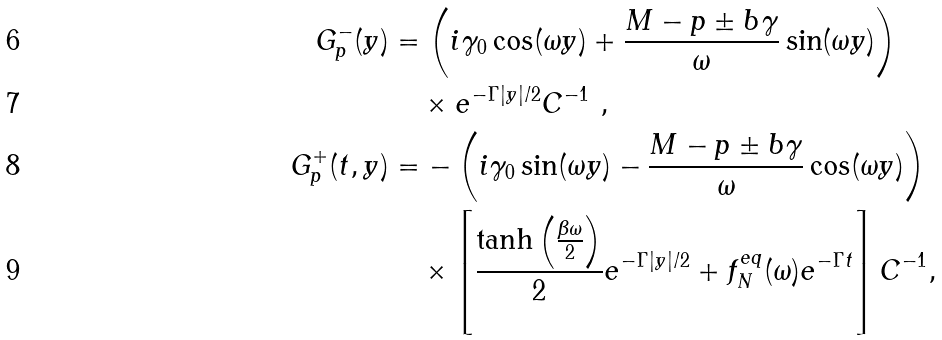Convert formula to latex. <formula><loc_0><loc_0><loc_500><loc_500>G ^ { - } _ { p } ( y ) & = \left ( i \gamma _ { 0 } \cos ( \omega y ) + \frac { M - { p } \pm b { \gamma } } { \omega } \sin ( \omega y ) \right ) \\ & \quad \times e ^ { - \Gamma | y | / 2 } C ^ { - 1 } \ , \\ G ^ { + } _ { p } ( t , y ) & = - \left ( i \gamma _ { 0 } \sin ( \omega y ) - \frac { M - { p } \pm b { \gamma } } { \omega } \cos ( \omega y ) \right ) \\ & \quad \times \left [ \frac { \tanh \left ( \frac { \beta \omega } { 2 } \right ) } { 2 } e ^ { - \Gamma | y | / 2 } + f _ { N } ^ { e q } ( \omega ) e ^ { - \Gamma t } \right ] C ^ { - 1 } ,</formula> 